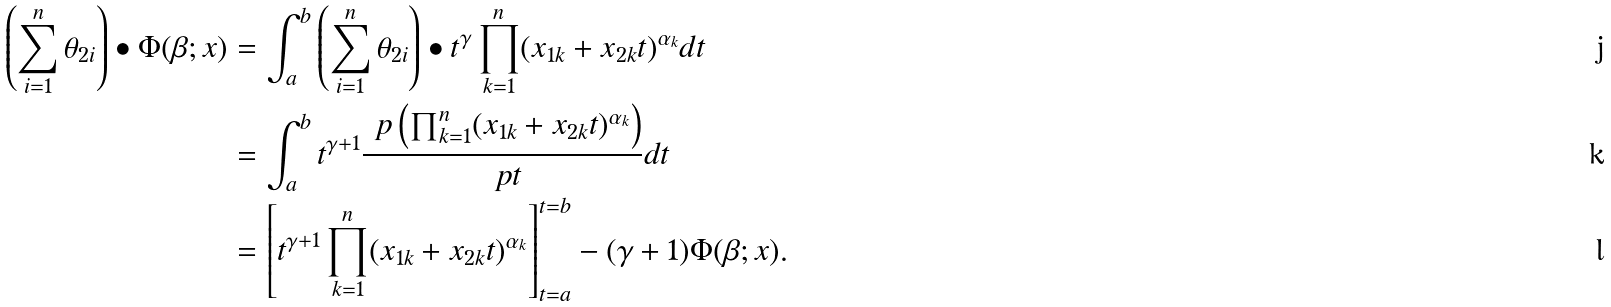<formula> <loc_0><loc_0><loc_500><loc_500>\left ( \sum _ { i = 1 } ^ { n } \theta _ { 2 i } \right ) \bullet \Phi ( \beta ; x ) & = \int _ { a } ^ { b } \left ( \sum _ { i = 1 } ^ { n } \theta _ { 2 i } \right ) \bullet t ^ { \gamma } \prod _ { k = 1 } ^ { n } ( x _ { 1 k } + x _ { 2 k } t ) ^ { \alpha _ { k } } d t \\ & = \int _ { a } ^ { b } t ^ { \gamma + 1 } \frac { \ p \left ( \prod _ { k = 1 } ^ { n } ( x _ { 1 k } + x _ { 2 k } t ) ^ { \alpha _ { k } } \right ) } { \ p t } d t \\ & = \left [ t ^ { \gamma + 1 } \prod _ { k = 1 } ^ { n } ( x _ { 1 k } + x _ { 2 k } t ) ^ { \alpha _ { k } } \right ] _ { t = a } ^ { t = b } - ( \gamma + 1 ) \Phi ( \beta ; x ) .</formula> 